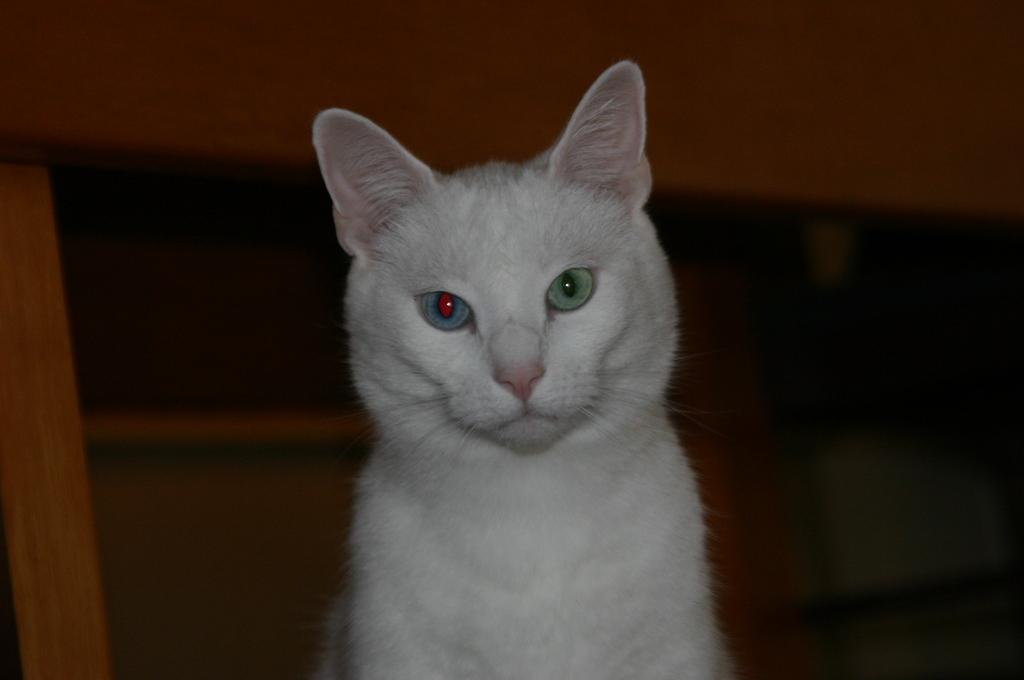What type of animal is in the image? There is a white-colored cat in the image. What can be observed about the background of the image? The background of the image appears to be dark. What type of beef can be seen in the image? There is no beef present in the image; it features a white-colored cat. Can you tell me how many geese are visible in the image? There are no geese present in the image; it features a white-colored cat. 